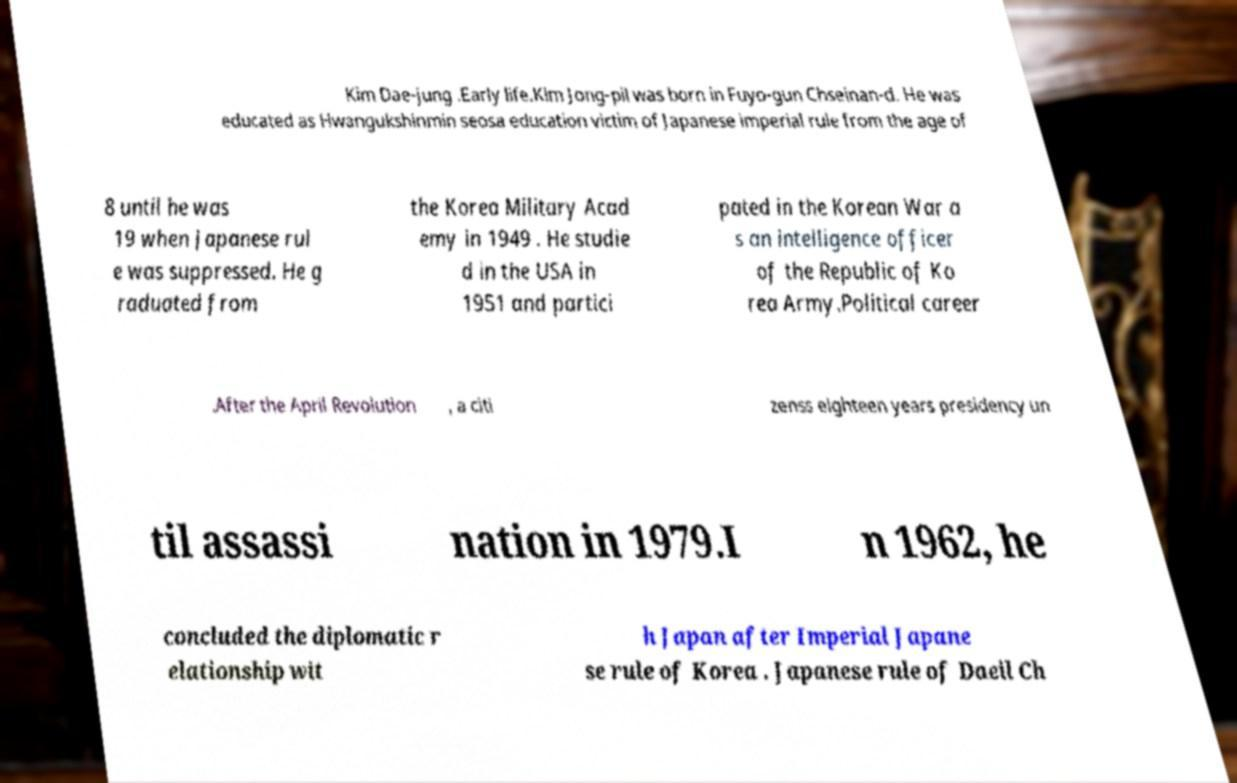Please identify and transcribe the text found in this image. Kim Dae-jung .Early life.Kim Jong-pil was born in Fuyo-gun Chseinan-d. He was educated as Hwangukshinmin seosa education victim of Japanese imperial rule from the age of 8 until he was 19 when Japanese rul e was suppressed. He g raduated from the Korea Military Acad emy in 1949 . He studie d in the USA in 1951 and partici pated in the Korean War a s an intelligence officer of the Republic of Ko rea Army.Political career .After the April Revolution , a citi zenss eighteen years presidency un til assassi nation in 1979.I n 1962, he concluded the diplomatic r elationship wit h Japan after Imperial Japane se rule of Korea . Japanese rule of Daeil Ch 